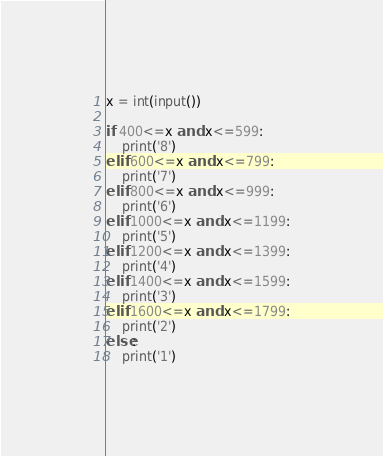Convert code to text. <code><loc_0><loc_0><loc_500><loc_500><_Python_>x = int(input())

if 400<=x and x<=599:
    print('8')
elif 600<=x and x<=799:
    print('7')
elif 800<=x and x<=999:
    print('6')
elif 1000<=x and x<=1199:
    print('5')
elif 1200<=x and x<=1399:
    print('4')
elif 1400<=x and x<=1599:
    print('3')
elif 1600<=x and x<=1799:
    print('2')
else:
    print('1')
</code> 